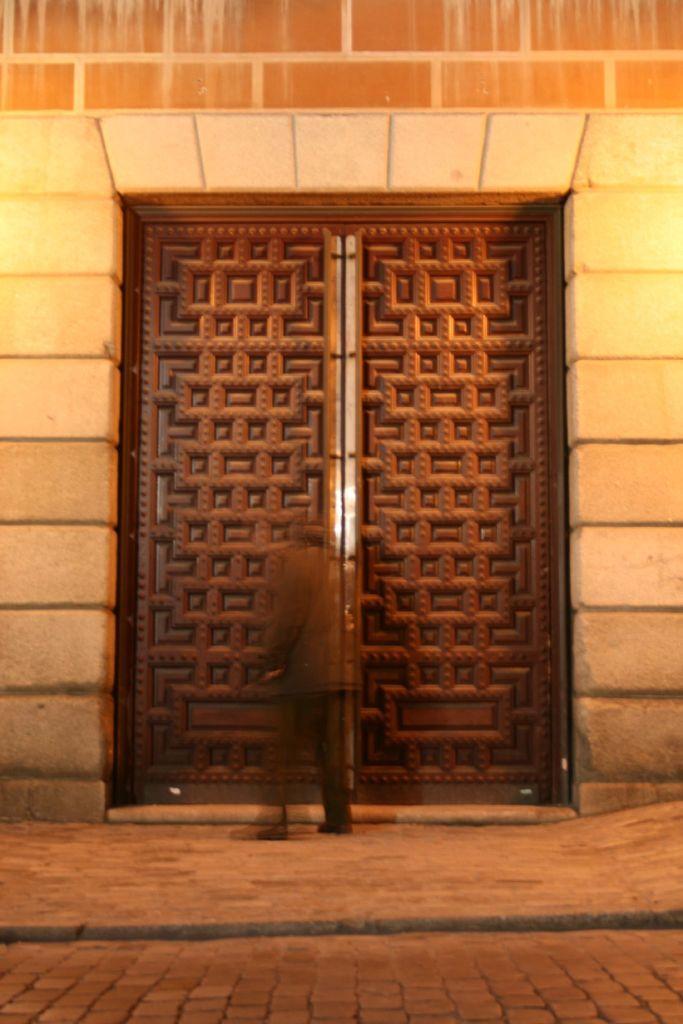In one or two sentences, can you explain what this image depicts? In this image there is a person standing in front of a building with the closed wooden door, behind the person there is pavement. 